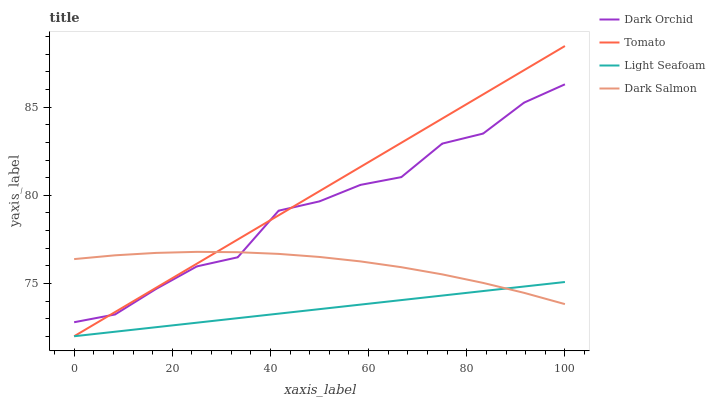Does Light Seafoam have the minimum area under the curve?
Answer yes or no. Yes. Does Tomato have the maximum area under the curve?
Answer yes or no. Yes. Does Dark Salmon have the minimum area under the curve?
Answer yes or no. No. Does Dark Salmon have the maximum area under the curve?
Answer yes or no. No. Is Light Seafoam the smoothest?
Answer yes or no. Yes. Is Dark Orchid the roughest?
Answer yes or no. Yes. Is Dark Salmon the smoothest?
Answer yes or no. No. Is Dark Salmon the roughest?
Answer yes or no. No. Does Tomato have the lowest value?
Answer yes or no. Yes. Does Dark Salmon have the lowest value?
Answer yes or no. No. Does Tomato have the highest value?
Answer yes or no. Yes. Does Dark Salmon have the highest value?
Answer yes or no. No. Is Light Seafoam less than Dark Orchid?
Answer yes or no. Yes. Is Dark Orchid greater than Light Seafoam?
Answer yes or no. Yes. Does Dark Salmon intersect Dark Orchid?
Answer yes or no. Yes. Is Dark Salmon less than Dark Orchid?
Answer yes or no. No. Is Dark Salmon greater than Dark Orchid?
Answer yes or no. No. Does Light Seafoam intersect Dark Orchid?
Answer yes or no. No. 